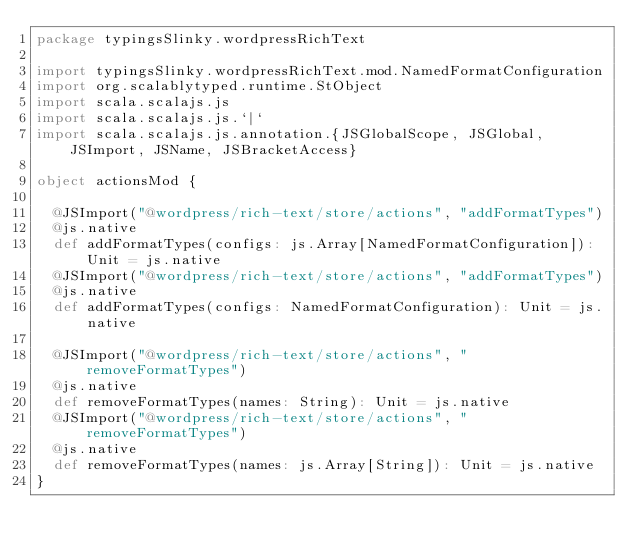Convert code to text. <code><loc_0><loc_0><loc_500><loc_500><_Scala_>package typingsSlinky.wordpressRichText

import typingsSlinky.wordpressRichText.mod.NamedFormatConfiguration
import org.scalablytyped.runtime.StObject
import scala.scalajs.js
import scala.scalajs.js.`|`
import scala.scalajs.js.annotation.{JSGlobalScope, JSGlobal, JSImport, JSName, JSBracketAccess}

object actionsMod {
  
  @JSImport("@wordpress/rich-text/store/actions", "addFormatTypes")
  @js.native
  def addFormatTypes(configs: js.Array[NamedFormatConfiguration]): Unit = js.native
  @JSImport("@wordpress/rich-text/store/actions", "addFormatTypes")
  @js.native
  def addFormatTypes(configs: NamedFormatConfiguration): Unit = js.native
  
  @JSImport("@wordpress/rich-text/store/actions", "removeFormatTypes")
  @js.native
  def removeFormatTypes(names: String): Unit = js.native
  @JSImport("@wordpress/rich-text/store/actions", "removeFormatTypes")
  @js.native
  def removeFormatTypes(names: js.Array[String]): Unit = js.native
}
</code> 